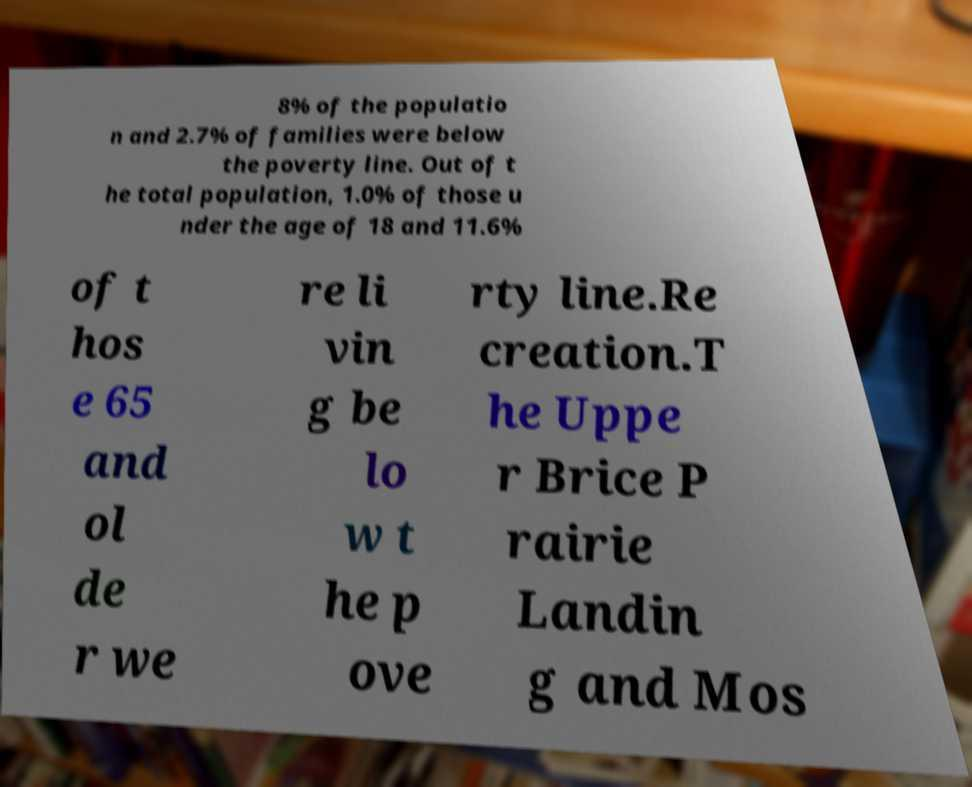Please read and relay the text visible in this image. What does it say? 8% of the populatio n and 2.7% of families were below the poverty line. Out of t he total population, 1.0% of those u nder the age of 18 and 11.6% of t hos e 65 and ol de r we re li vin g be lo w t he p ove rty line.Re creation.T he Uppe r Brice P rairie Landin g and Mos 